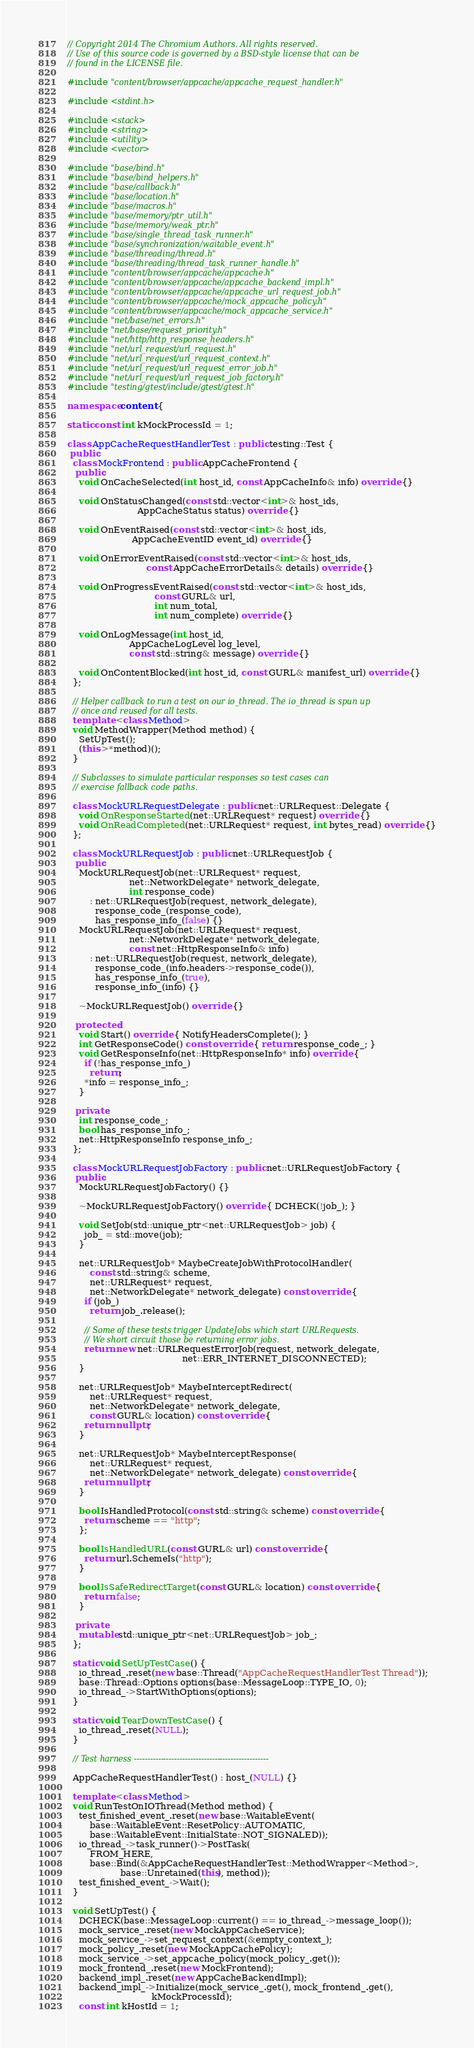Convert code to text. <code><loc_0><loc_0><loc_500><loc_500><_C++_>// Copyright 2014 The Chromium Authors. All rights reserved.
// Use of this source code is governed by a BSD-style license that can be
// found in the LICENSE file.

#include "content/browser/appcache/appcache_request_handler.h"

#include <stdint.h>

#include <stack>
#include <string>
#include <utility>
#include <vector>

#include "base/bind.h"
#include "base/bind_helpers.h"
#include "base/callback.h"
#include "base/location.h"
#include "base/macros.h"
#include "base/memory/ptr_util.h"
#include "base/memory/weak_ptr.h"
#include "base/single_thread_task_runner.h"
#include "base/synchronization/waitable_event.h"
#include "base/threading/thread.h"
#include "base/threading/thread_task_runner_handle.h"
#include "content/browser/appcache/appcache.h"
#include "content/browser/appcache/appcache_backend_impl.h"
#include "content/browser/appcache/appcache_url_request_job.h"
#include "content/browser/appcache/mock_appcache_policy.h"
#include "content/browser/appcache/mock_appcache_service.h"
#include "net/base/net_errors.h"
#include "net/base/request_priority.h"
#include "net/http/http_response_headers.h"
#include "net/url_request/url_request.h"
#include "net/url_request/url_request_context.h"
#include "net/url_request/url_request_error_job.h"
#include "net/url_request/url_request_job_factory.h"
#include "testing/gtest/include/gtest/gtest.h"

namespace content {

static const int kMockProcessId = 1;

class AppCacheRequestHandlerTest : public testing::Test {
 public:
  class MockFrontend : public AppCacheFrontend {
   public:
    void OnCacheSelected(int host_id, const AppCacheInfo& info) override {}

    void OnStatusChanged(const std::vector<int>& host_ids,
                         AppCacheStatus status) override {}

    void OnEventRaised(const std::vector<int>& host_ids,
                       AppCacheEventID event_id) override {}

    void OnErrorEventRaised(const std::vector<int>& host_ids,
                            const AppCacheErrorDetails& details) override {}

    void OnProgressEventRaised(const std::vector<int>& host_ids,
                               const GURL& url,
                               int num_total,
                               int num_complete) override {}

    void OnLogMessage(int host_id,
                      AppCacheLogLevel log_level,
                      const std::string& message) override {}

    void OnContentBlocked(int host_id, const GURL& manifest_url) override {}
  };

  // Helper callback to run a test on our io_thread. The io_thread is spun up
  // once and reused for all tests.
  template <class Method>
  void MethodWrapper(Method method) {
    SetUpTest();
    (this->*method)();
  }

  // Subclasses to simulate particular responses so test cases can
  // exercise fallback code paths.

  class MockURLRequestDelegate : public net::URLRequest::Delegate {
    void OnResponseStarted(net::URLRequest* request) override {}
    void OnReadCompleted(net::URLRequest* request, int bytes_read) override {}
  };

  class MockURLRequestJob : public net::URLRequestJob {
   public:
    MockURLRequestJob(net::URLRequest* request,
                      net::NetworkDelegate* network_delegate,
                      int response_code)
        : net::URLRequestJob(request, network_delegate),
          response_code_(response_code),
          has_response_info_(false) {}
    MockURLRequestJob(net::URLRequest* request,
                      net::NetworkDelegate* network_delegate,
                      const net::HttpResponseInfo& info)
        : net::URLRequestJob(request, network_delegate),
          response_code_(info.headers->response_code()),
          has_response_info_(true),
          response_info_(info) {}

    ~MockURLRequestJob() override {}

   protected:
    void Start() override { NotifyHeadersComplete(); }
    int GetResponseCode() const override { return response_code_; }
    void GetResponseInfo(net::HttpResponseInfo* info) override {
      if (!has_response_info_)
        return;
      *info = response_info_;
    }

   private:
    int response_code_;
    bool has_response_info_;
    net::HttpResponseInfo response_info_;
  };

  class MockURLRequestJobFactory : public net::URLRequestJobFactory {
   public:
    MockURLRequestJobFactory() {}

    ~MockURLRequestJobFactory() override { DCHECK(!job_); }

    void SetJob(std::unique_ptr<net::URLRequestJob> job) {
      job_ = std::move(job);
    }

    net::URLRequestJob* MaybeCreateJobWithProtocolHandler(
        const std::string& scheme,
        net::URLRequest* request,
        net::NetworkDelegate* network_delegate) const override {
      if (job_)
        return job_.release();

      // Some of these tests trigger UpdateJobs which start URLRequests.
      // We short circuit those be returning error jobs.
      return new net::URLRequestErrorJob(request, network_delegate,
                                         net::ERR_INTERNET_DISCONNECTED);
    }

    net::URLRequestJob* MaybeInterceptRedirect(
        net::URLRequest* request,
        net::NetworkDelegate* network_delegate,
        const GURL& location) const override {
      return nullptr;
    }

    net::URLRequestJob* MaybeInterceptResponse(
        net::URLRequest* request,
        net::NetworkDelegate* network_delegate) const override {
      return nullptr;
    }

    bool IsHandledProtocol(const std::string& scheme) const override {
      return scheme == "http";
    };

    bool IsHandledURL(const GURL& url) const override {
      return url.SchemeIs("http");
    }

    bool IsSafeRedirectTarget(const GURL& location) const override {
      return false;
    }

   private:
    mutable std::unique_ptr<net::URLRequestJob> job_;
  };

  static void SetUpTestCase() {
    io_thread_.reset(new base::Thread("AppCacheRequestHandlerTest Thread"));
    base::Thread::Options options(base::MessageLoop::TYPE_IO, 0);
    io_thread_->StartWithOptions(options);
  }

  static void TearDownTestCase() {
    io_thread_.reset(NULL);
  }

  // Test harness --------------------------------------------------

  AppCacheRequestHandlerTest() : host_(NULL) {}

  template <class Method>
  void RunTestOnIOThread(Method method) {
    test_finished_event_.reset(new base::WaitableEvent(
        base::WaitableEvent::ResetPolicy::AUTOMATIC,
        base::WaitableEvent::InitialState::NOT_SIGNALED));
    io_thread_->task_runner()->PostTask(
        FROM_HERE,
        base::Bind(&AppCacheRequestHandlerTest::MethodWrapper<Method>,
                   base::Unretained(this), method));
    test_finished_event_->Wait();
  }

  void SetUpTest() {
    DCHECK(base::MessageLoop::current() == io_thread_->message_loop());
    mock_service_.reset(new MockAppCacheService);
    mock_service_->set_request_context(&empty_context_);
    mock_policy_.reset(new MockAppCachePolicy);
    mock_service_->set_appcache_policy(mock_policy_.get());
    mock_frontend_.reset(new MockFrontend);
    backend_impl_.reset(new AppCacheBackendImpl);
    backend_impl_->Initialize(mock_service_.get(), mock_frontend_.get(),
                              kMockProcessId);
    const int kHostId = 1;</code> 